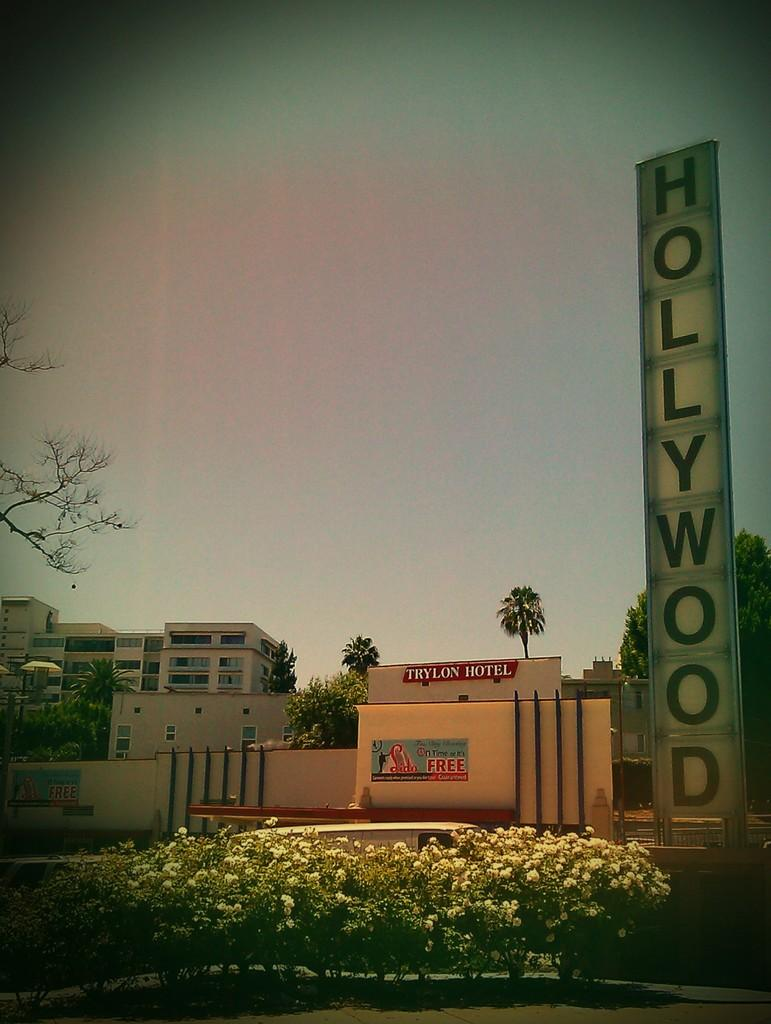What type of vegetation can be seen in the image? There are plants and flowers in the image. What type of structures are visible in the image? There are buildings in the image. What type of natural elements can be seen in the image? There are trees in the image. What part of the natural environment is visible in the image? The sky is visible in the image. What type of screw can be seen in the image? There is no screw present in the image. What is the plot of the story being told in the image? The image does not depict a story or plot; it is a still image of plants, flowers, buildings, trees, and the sky. 